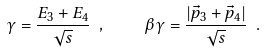Convert formula to latex. <formula><loc_0><loc_0><loc_500><loc_500>\gamma = \frac { E _ { 3 } + E _ { 4 } } { \sqrt { s } } \ , \quad \beta \gamma = \frac { | \vec { p } _ { 3 } + \vec { p } _ { 4 } | } { \sqrt { s } } \ .</formula> 